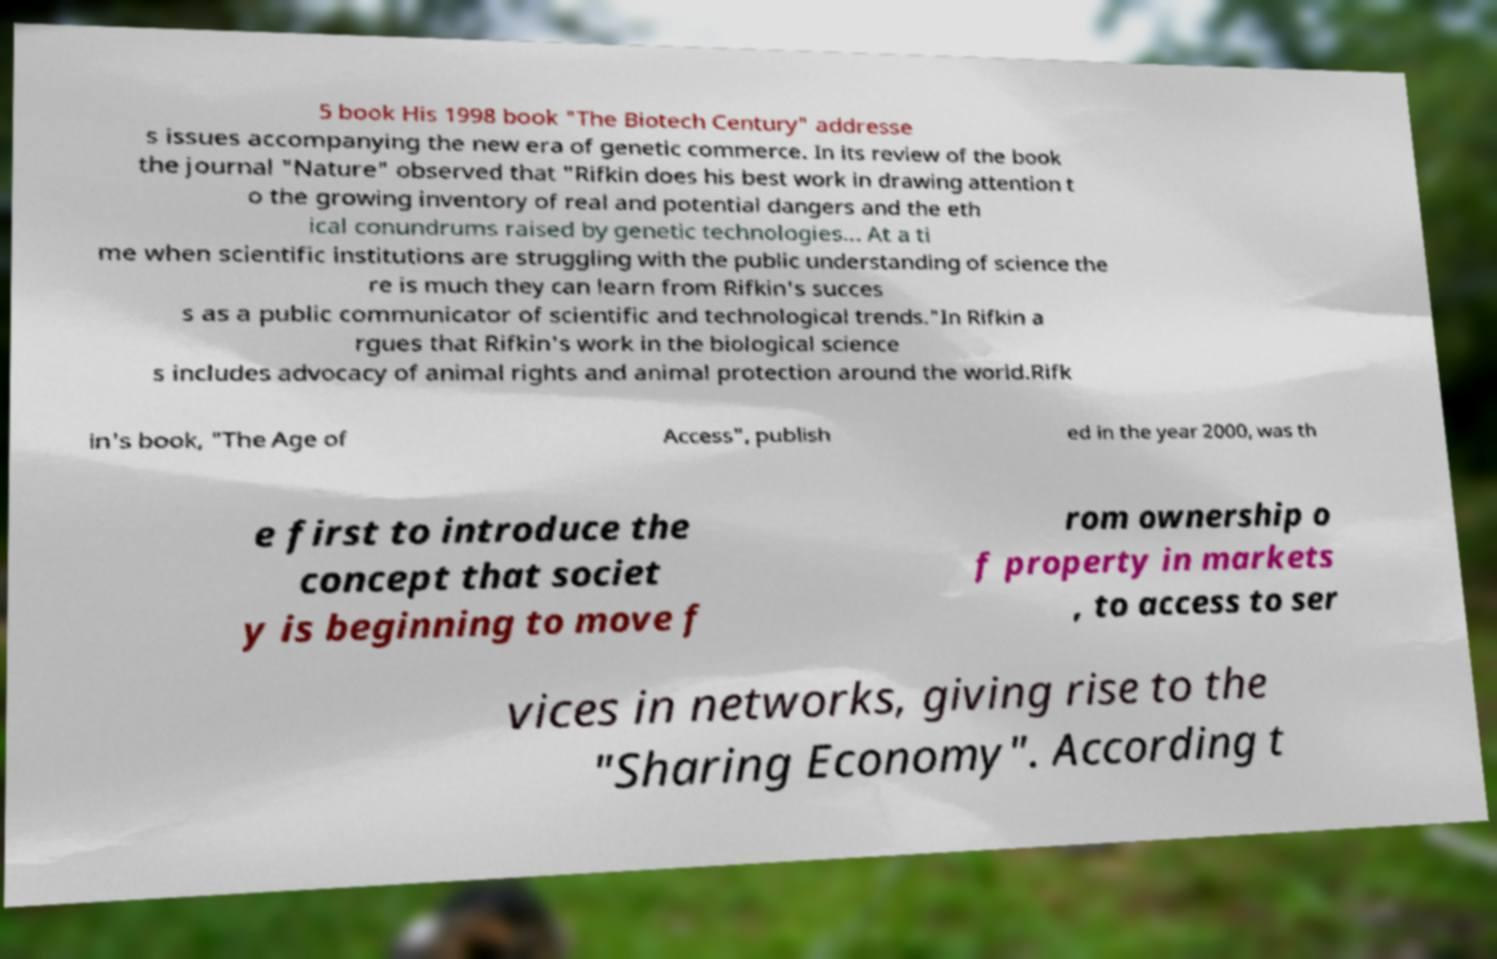Please read and relay the text visible in this image. What does it say? 5 book His 1998 book "The Biotech Century" addresse s issues accompanying the new era of genetic commerce. In its review of the book the journal "Nature" observed that "Rifkin does his best work in drawing attention t o the growing inventory of real and potential dangers and the eth ical conundrums raised by genetic technologies... At a ti me when scientific institutions are struggling with the public understanding of science the re is much they can learn from Rifkin's succes s as a public communicator of scientific and technological trends."In Rifkin a rgues that Rifkin's work in the biological science s includes advocacy of animal rights and animal protection around the world.Rifk in's book, "The Age of Access", publish ed in the year 2000, was th e first to introduce the concept that societ y is beginning to move f rom ownership o f property in markets , to access to ser vices in networks, giving rise to the "Sharing Economy". According t 